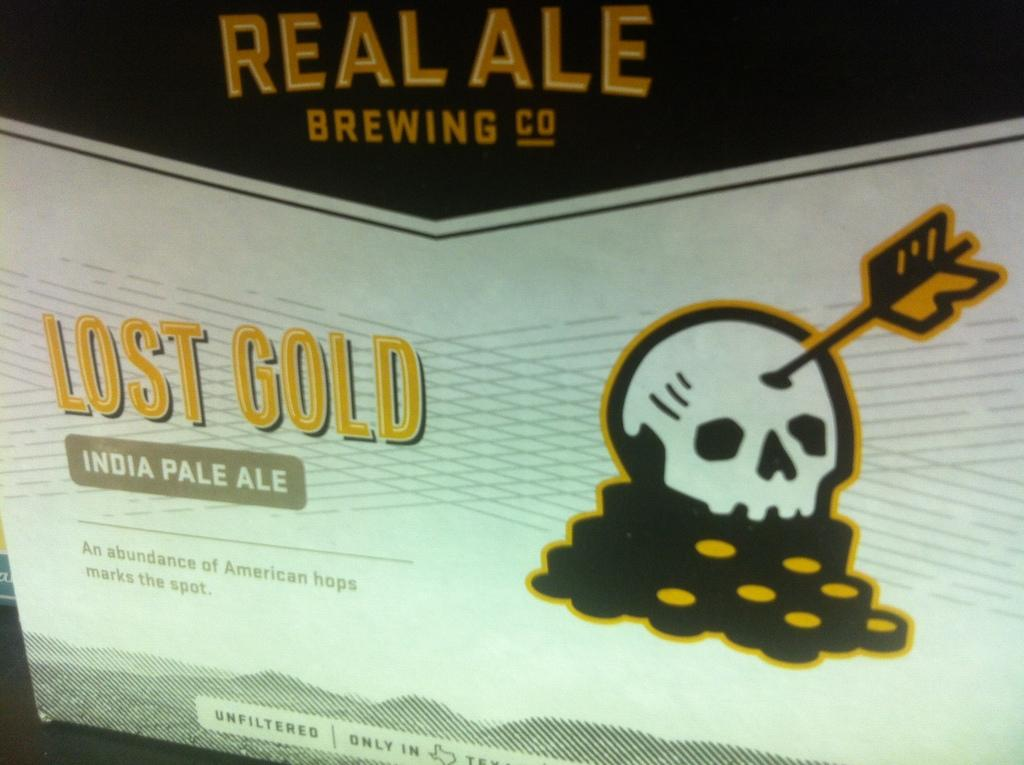What is the main feature of the image? There is a board with text and images in the image. Can you describe the content of the board? The board contains text and images, but the specific content is not mentioned in the facts. Is there anything else visible in the image besides the board? Yes, there is an object behind the board on the left side of the image. What type of design can be seen on the bed in the image? There is no bed present in the image; it only features a board with text and images and an object behind the board on the left side. 